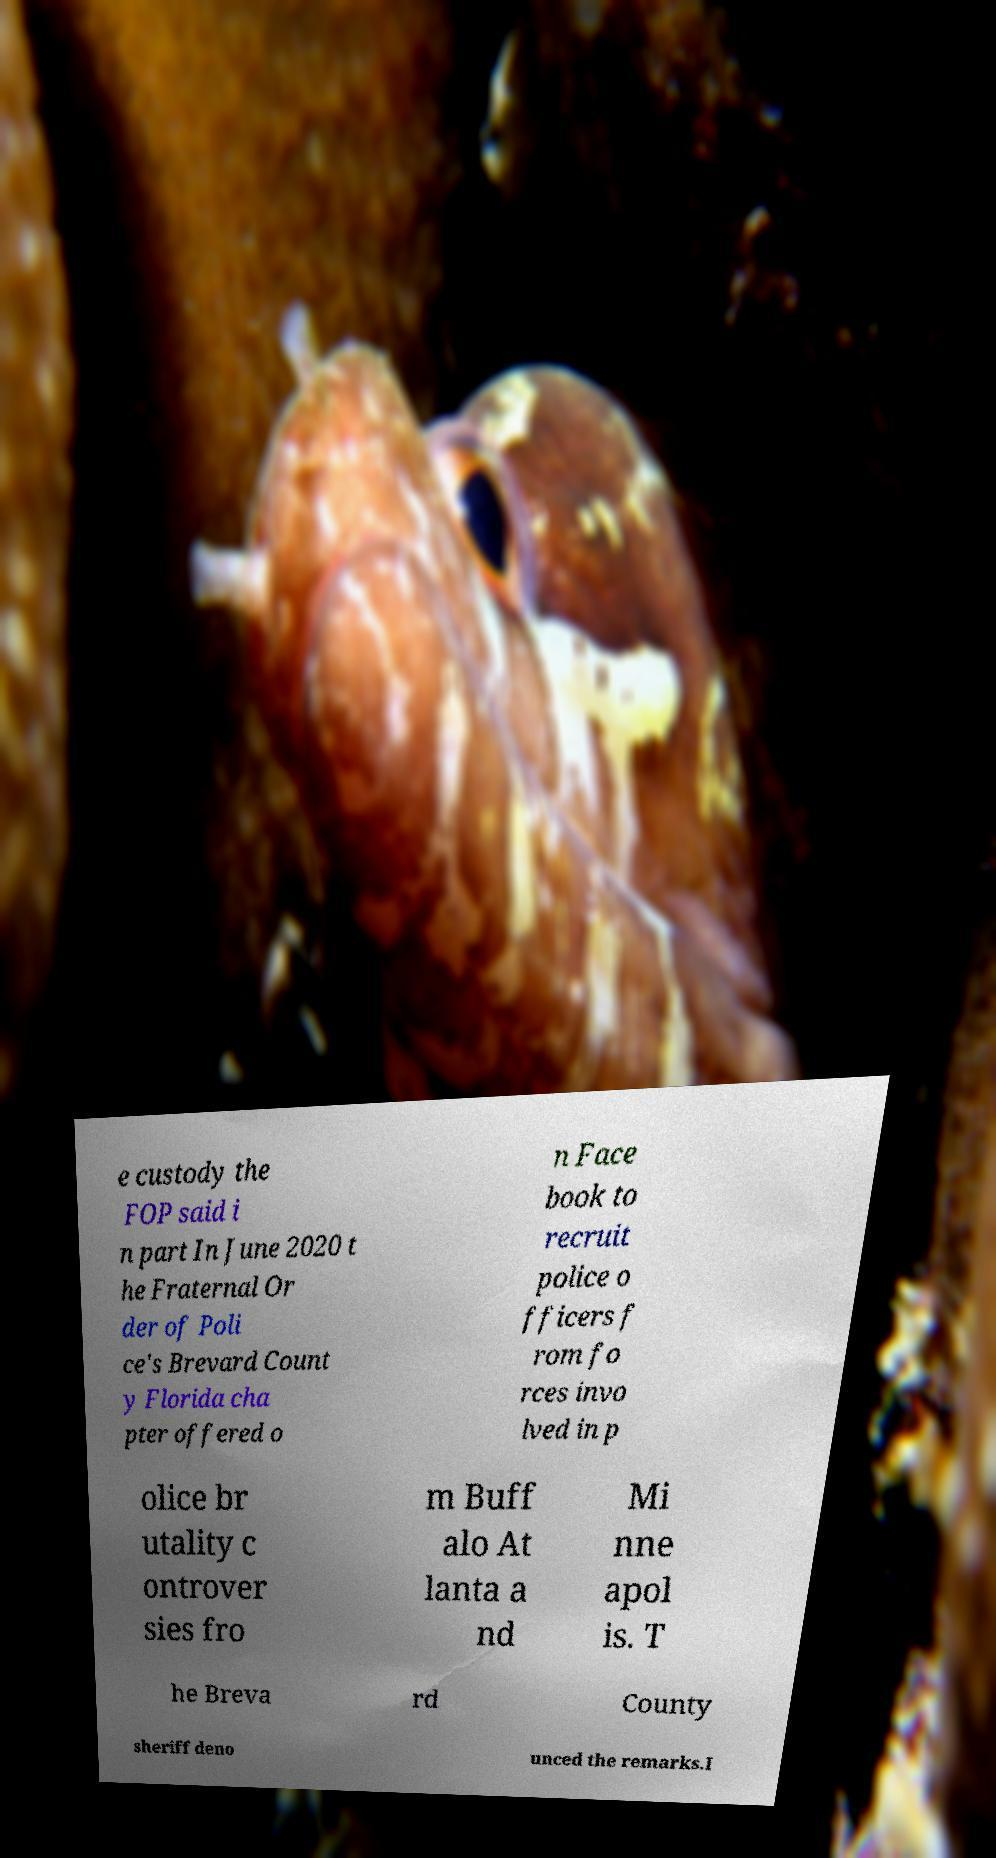Could you extract and type out the text from this image? e custody the FOP said i n part In June 2020 t he Fraternal Or der of Poli ce's Brevard Count y Florida cha pter offered o n Face book to recruit police o fficers f rom fo rces invo lved in p olice br utality c ontrover sies fro m Buff alo At lanta a nd Mi nne apol is. T he Breva rd County sheriff deno unced the remarks.I 